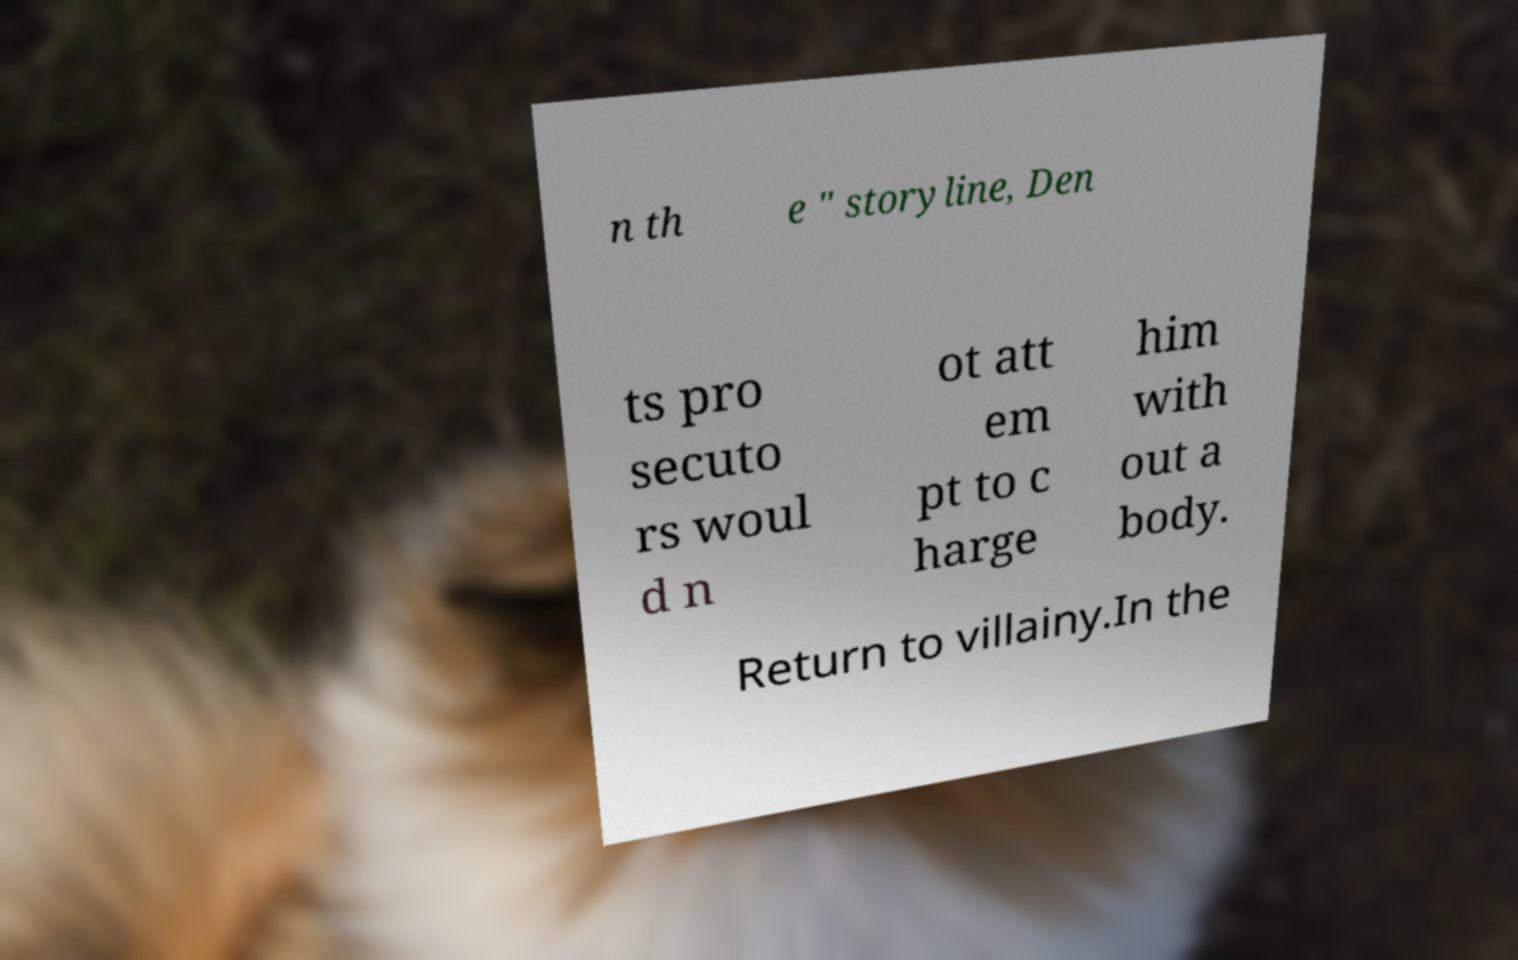Can you read and provide the text displayed in the image?This photo seems to have some interesting text. Can you extract and type it out for me? n th e " storyline, Den ts pro secuto rs woul d n ot att em pt to c harge him with out a body. Return to villainy.In the 